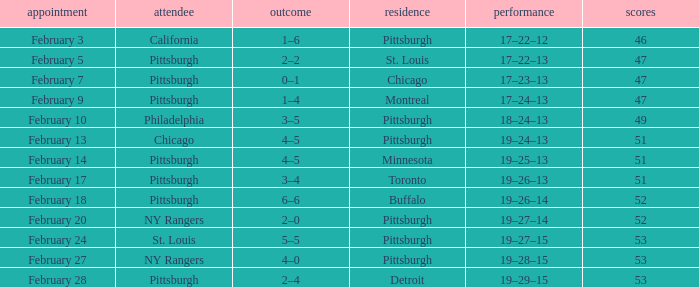Write the full table. {'header': ['appointment', 'attendee', 'outcome', 'residence', 'performance', 'scores'], 'rows': [['February 3', 'California', '1–6', 'Pittsburgh', '17–22–12', '46'], ['February 5', 'Pittsburgh', '2–2', 'St. Louis', '17–22–13', '47'], ['February 7', 'Pittsburgh', '0–1', 'Chicago', '17–23–13', '47'], ['February 9', 'Pittsburgh', '1–4', 'Montreal', '17–24–13', '47'], ['February 10', 'Philadelphia', '3–5', 'Pittsburgh', '18–24–13', '49'], ['February 13', 'Chicago', '4–5', 'Pittsburgh', '19–24–13', '51'], ['February 14', 'Pittsburgh', '4–5', 'Minnesota', '19–25–13', '51'], ['February 17', 'Pittsburgh', '3–4', 'Toronto', '19–26–13', '51'], ['February 18', 'Pittsburgh', '6–6', 'Buffalo', '19–26–14', '52'], ['February 20', 'NY Rangers', '2–0', 'Pittsburgh', '19–27–14', '52'], ['February 24', 'St. Louis', '5–5', 'Pittsburgh', '19–27–15', '53'], ['February 27', 'NY Rangers', '4–0', 'Pittsburgh', '19–28–15', '53'], ['February 28', 'Pittsburgh', '2–4', 'Detroit', '19–29–15', '53']]} Which Score has a Date of february 9? 1–4. 